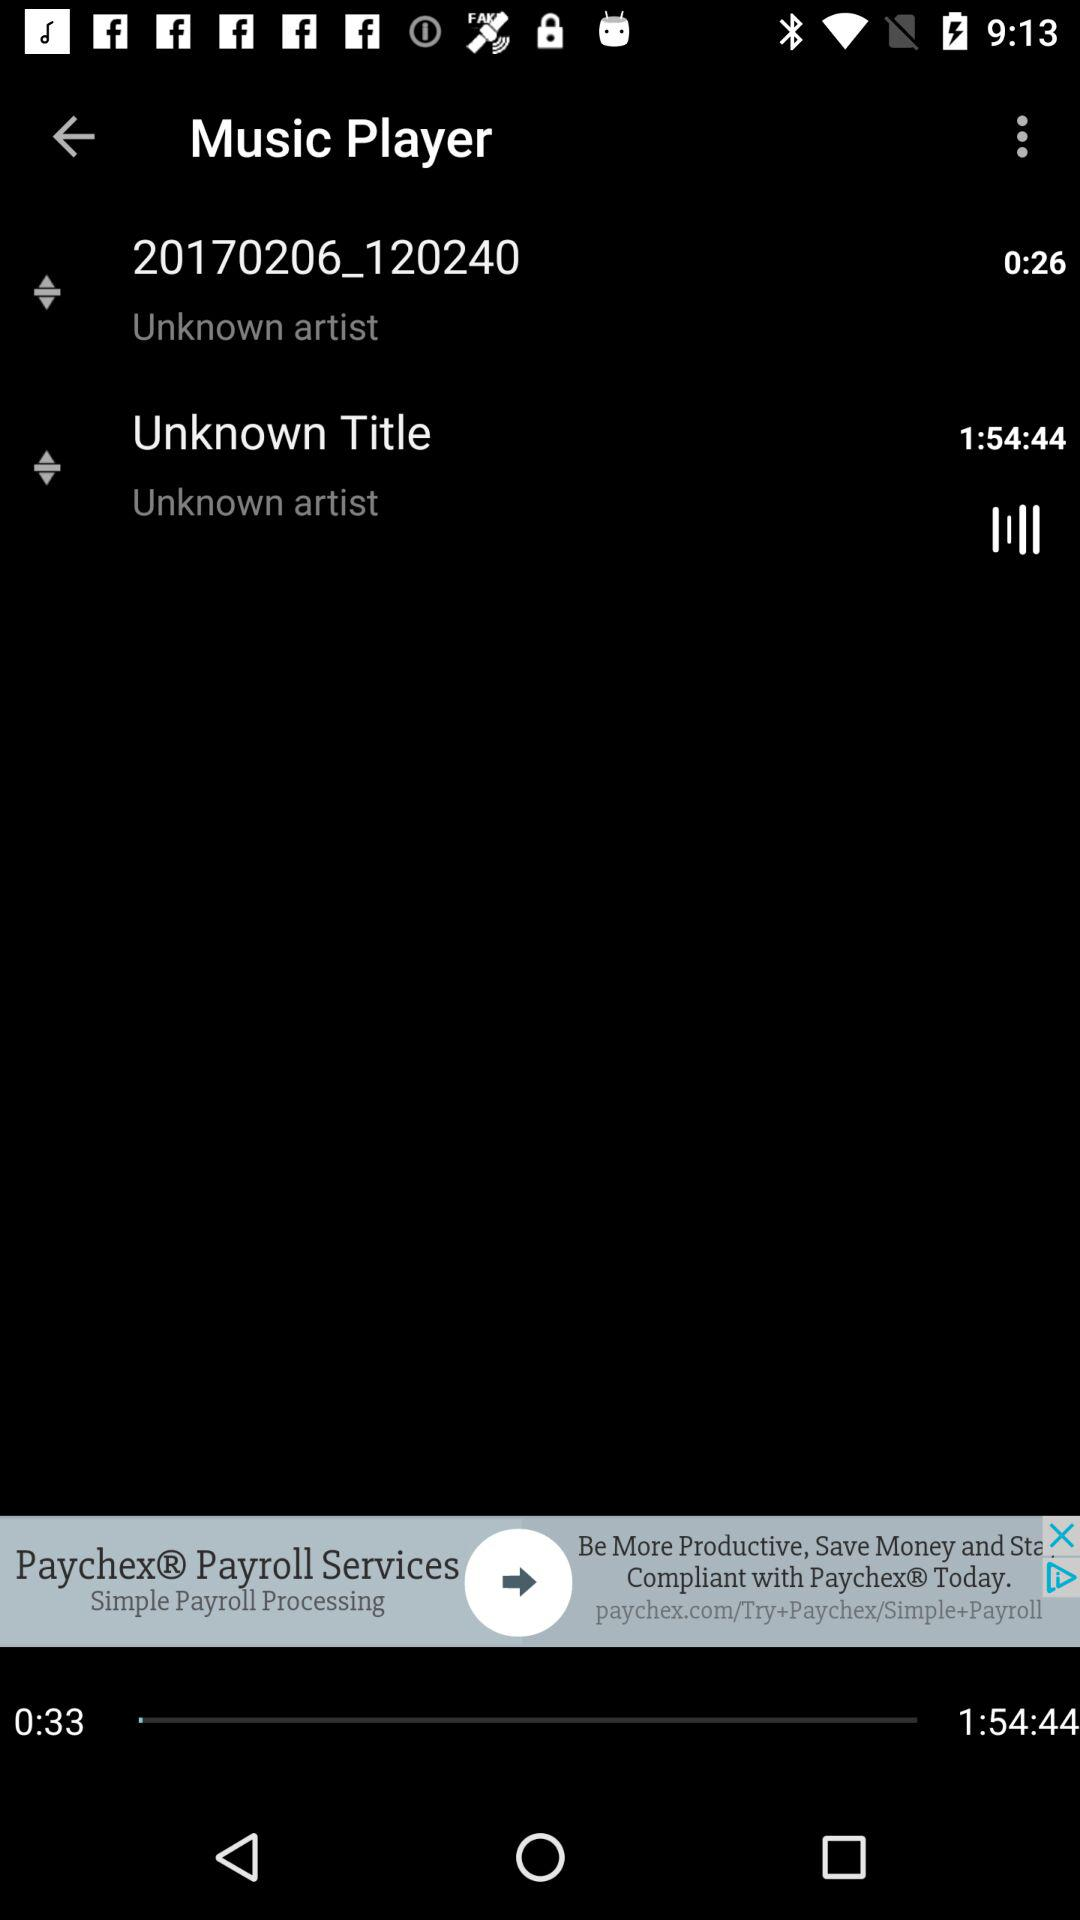How long is the first song?
Answer the question using a single word or phrase. 0:26 